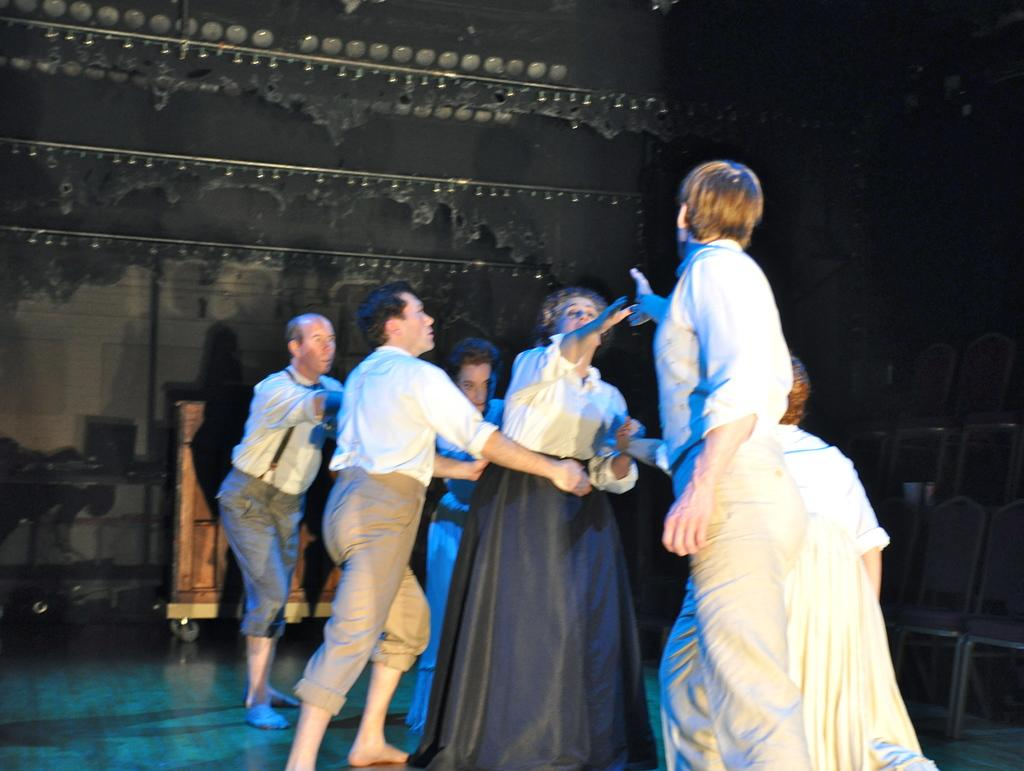What is happening in the image? There are people acting in the image. Can you describe any specific objects or features in the background of the image? Yes, there is a desk with wheels in the background of the image. What type of cabbage can be seen growing in the image? There is no cabbage present in the image. How many birds can be seen flying in the image? There are no birds present in the image. 